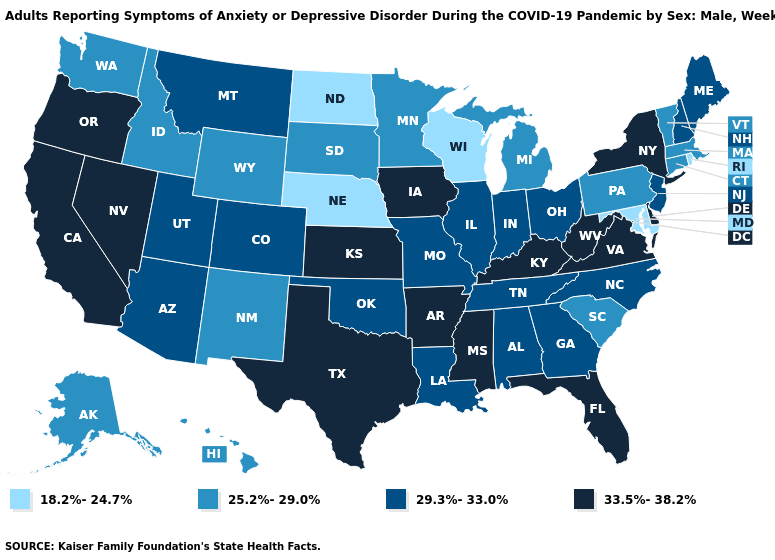What is the value of Ohio?
Short answer required. 29.3%-33.0%. What is the lowest value in states that border Alabama?
Quick response, please. 29.3%-33.0%. Which states have the lowest value in the USA?
Write a very short answer. Maryland, Nebraska, North Dakota, Rhode Island, Wisconsin. Name the states that have a value in the range 29.3%-33.0%?
Quick response, please. Alabama, Arizona, Colorado, Georgia, Illinois, Indiana, Louisiana, Maine, Missouri, Montana, New Hampshire, New Jersey, North Carolina, Ohio, Oklahoma, Tennessee, Utah. Name the states that have a value in the range 25.2%-29.0%?
Answer briefly. Alaska, Connecticut, Hawaii, Idaho, Massachusetts, Michigan, Minnesota, New Mexico, Pennsylvania, South Carolina, South Dakota, Vermont, Washington, Wyoming. Name the states that have a value in the range 25.2%-29.0%?
Concise answer only. Alaska, Connecticut, Hawaii, Idaho, Massachusetts, Michigan, Minnesota, New Mexico, Pennsylvania, South Carolina, South Dakota, Vermont, Washington, Wyoming. What is the value of Nebraska?
Answer briefly. 18.2%-24.7%. Which states have the lowest value in the USA?
Give a very brief answer. Maryland, Nebraska, North Dakota, Rhode Island, Wisconsin. Does Texas have the highest value in the USA?
Give a very brief answer. Yes. What is the value of Wisconsin?
Answer briefly. 18.2%-24.7%. What is the value of New Jersey?
Give a very brief answer. 29.3%-33.0%. What is the value of South Carolina?
Concise answer only. 25.2%-29.0%. 